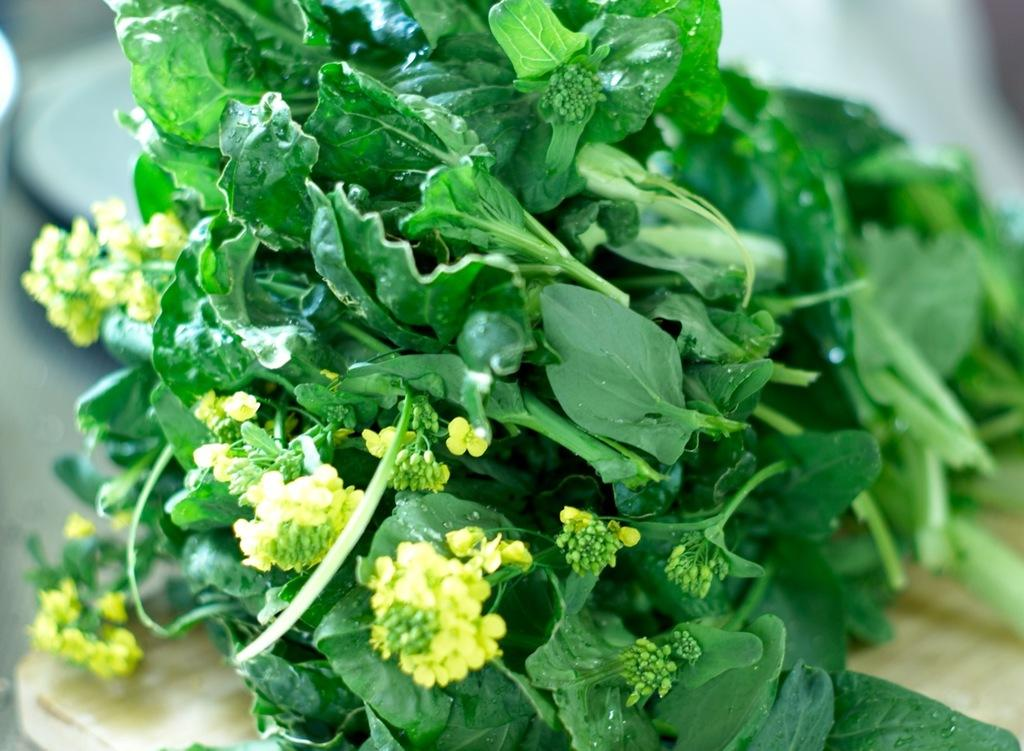What color are the leaves in the image? The leaves in the image are green. What other color can be seen in the image besides green? There are yellow buds in the image. How would you describe the overall clarity of the image? The image is slightly blurry in the background. What type of authority figure can be seen in the image? There is no authority figure present in the image; it features green leaves and yellow buds. How many steps are visible in the image? There are no steps visible in the image; it only contains green leaves and yellow buds. 